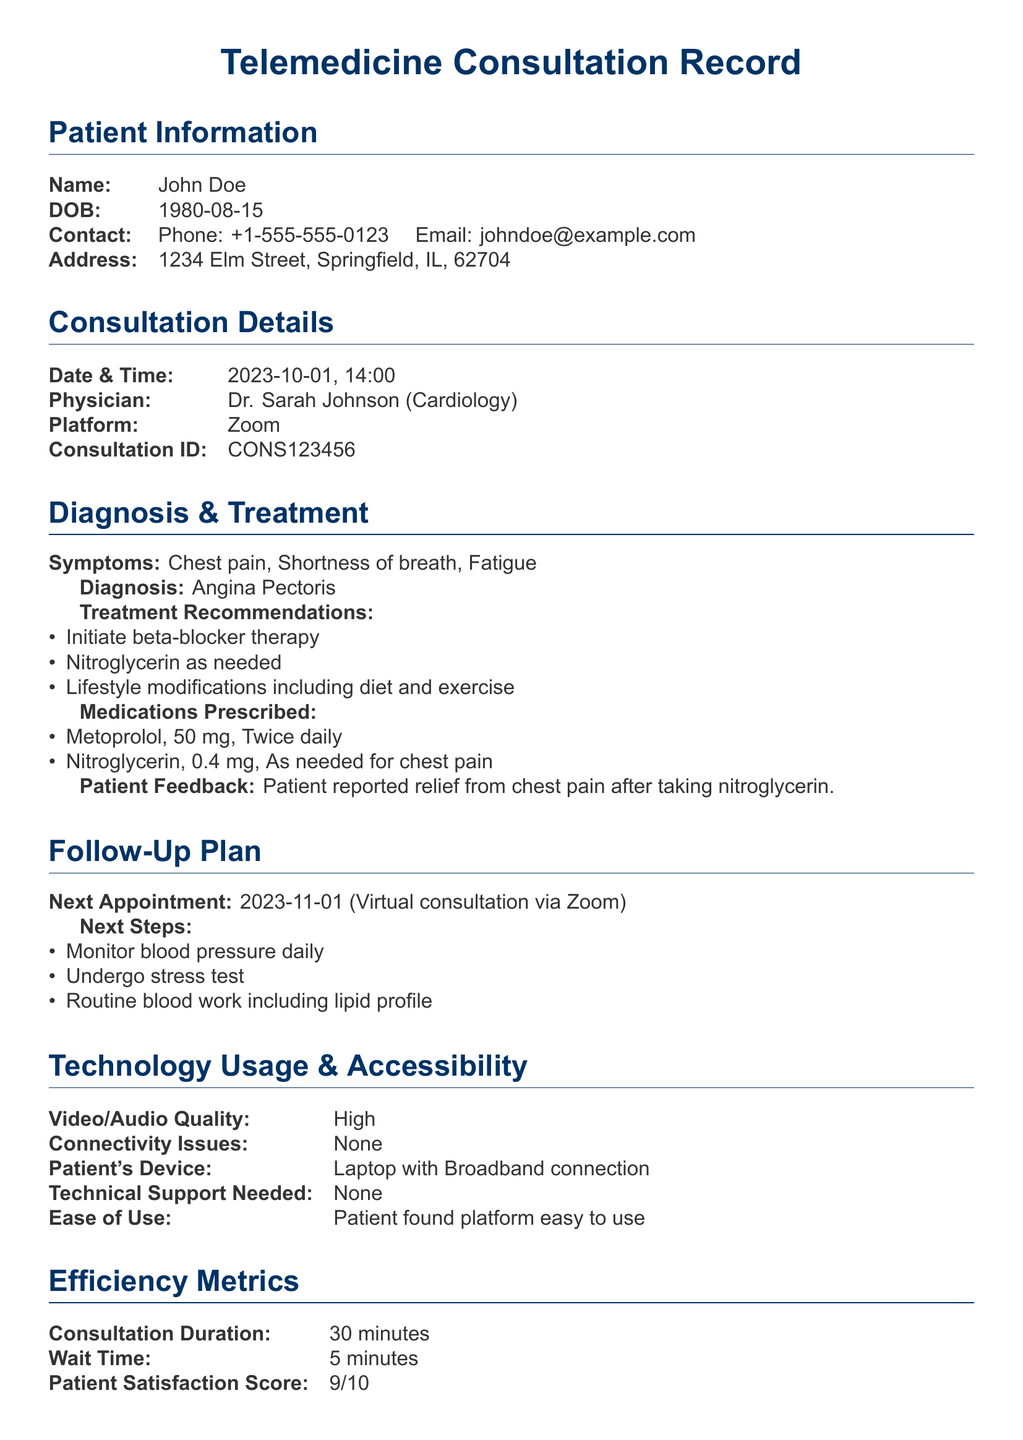What is the patient's name? The patient's name is provided in the Patient Information section of the document.
Answer: John Doe What is the date and time of the consultation? The date and time of the consultation are listed under Consultation Details.
Answer: 2023-10-01, 14:00 Who is the physician assigned to the patient? The physician's name is found in the Consultation Details section.
Answer: Dr. Sarah Johnson What was the diagnosis for the patient? The diagnosis is presented in the Diagnosis & Treatment section of the document.
Answer: Angina Pectoris What feedback did the patient give concerning treatment? Patient feedback is included in the Diagnosis & Treatment section.
Answer: Relief from chest pain after taking nitroglycerin What platform was used for the telemedicine consultation? The platform for the consultation is specified in the Consultation Details section.
Answer: Zoom What is the next appointment date? The next appointment date is mentioned in the Follow-Up Plan section.
Answer: 2023-11-01 What was the patient satisfaction score? The patient satisfaction score is reflected in the Efficiency Metrics section of the document.
Answer: 9/10 Was there any technical support needed during the consultation? The need for technical support is addressed in the Technology Usage & Accessibility section.
Answer: None 